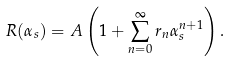<formula> <loc_0><loc_0><loc_500><loc_500>R ( \alpha _ { s } ) = A \left ( 1 + \sum _ { n = 0 } ^ { \infty } r _ { n } \alpha _ { s } ^ { n + 1 } \right ) .</formula> 